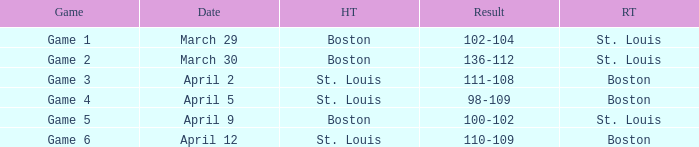What is the upshot of the game on april 9? 100-102. 